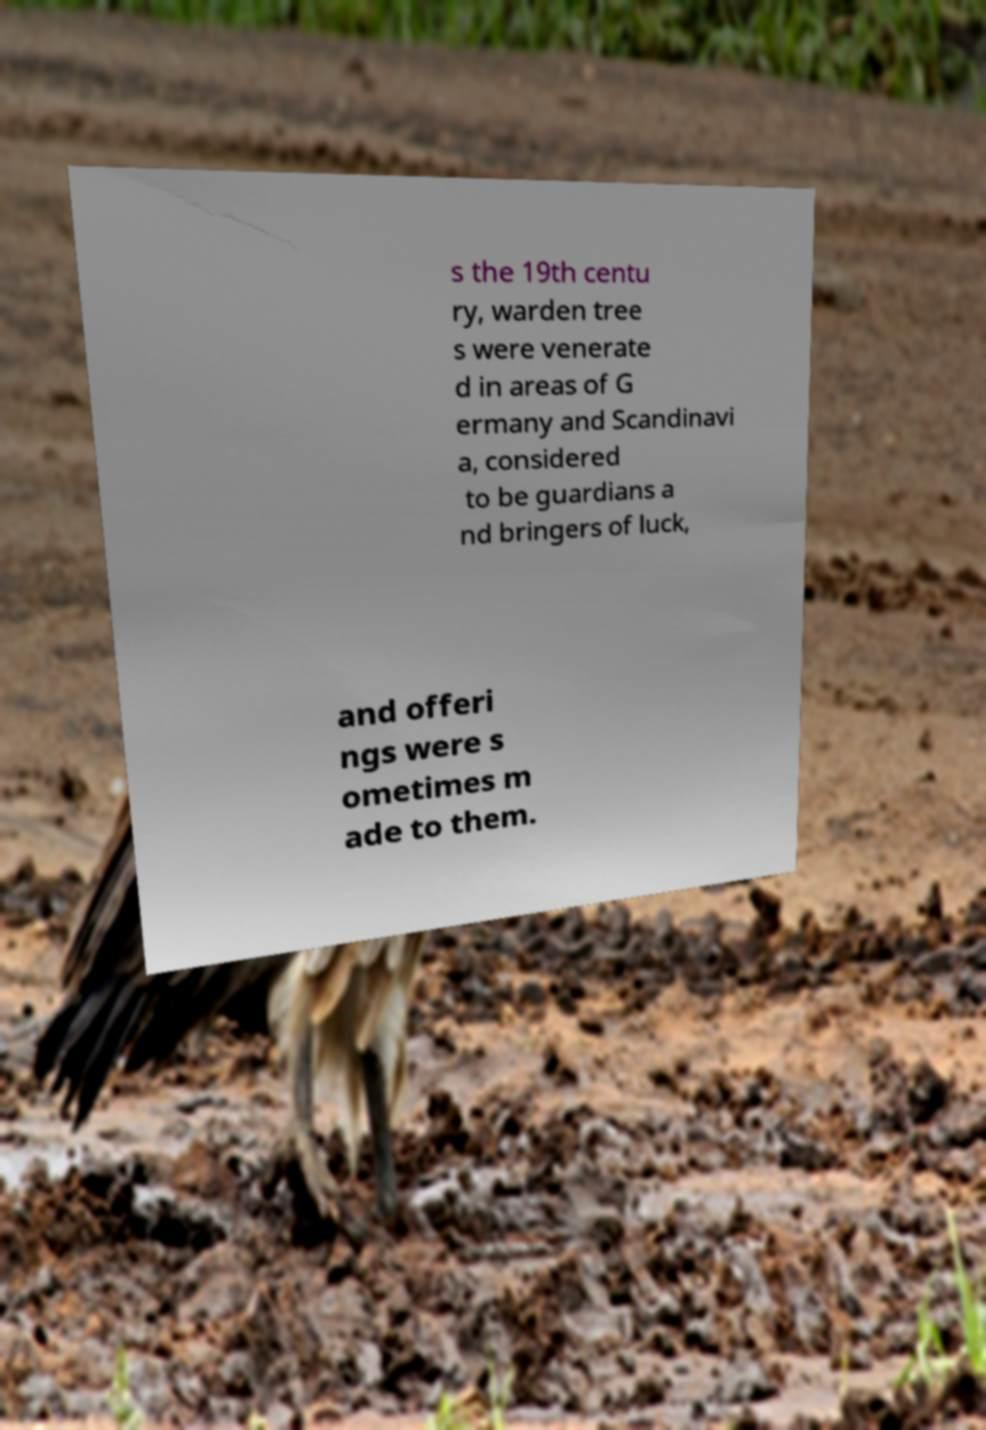Please read and relay the text visible in this image. What does it say? s the 19th centu ry, warden tree s were venerate d in areas of G ermany and Scandinavi a, considered to be guardians a nd bringers of luck, and offeri ngs were s ometimes m ade to them. 